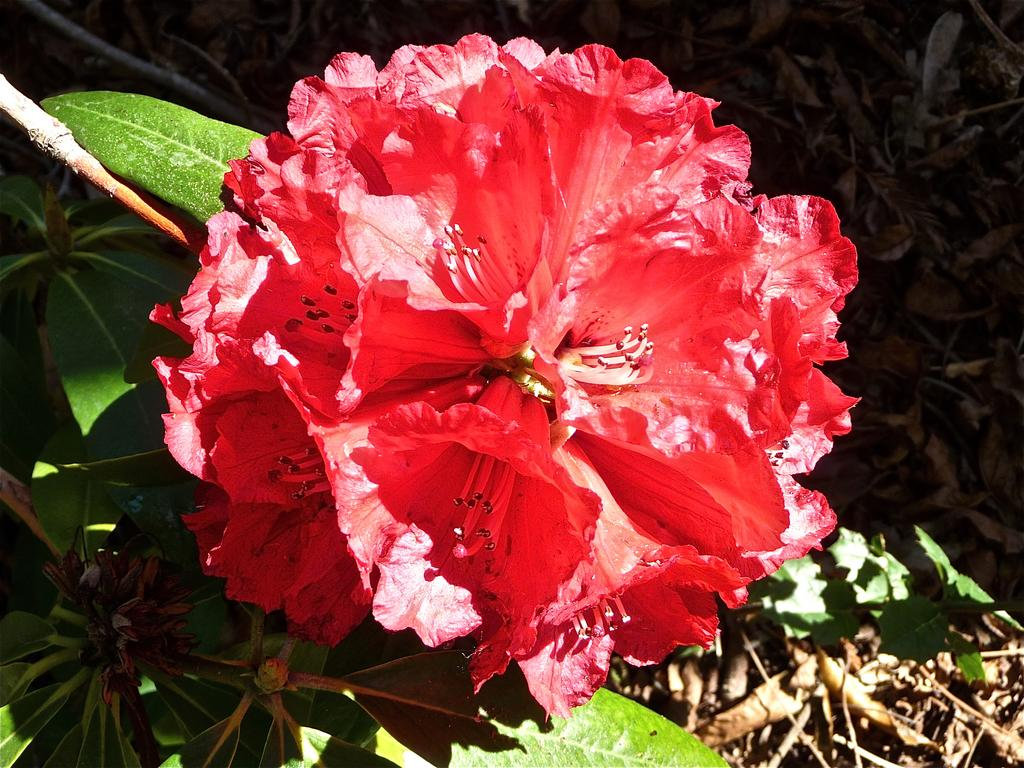What type of plant is present in the image? There is a plant with a flower in the image. What color is the flower on the plant? The flower is red in color. What are the characteristics of the flower? The flower has petals. What else can be seen in the image besides the flowering plant? There are dried plants visible in the image. What type of toy is being used to sprinkle salt on the health of the plant in the image? There is no toy, salt, or indication of health in the image; it only features a flowering plant and dried plants. 